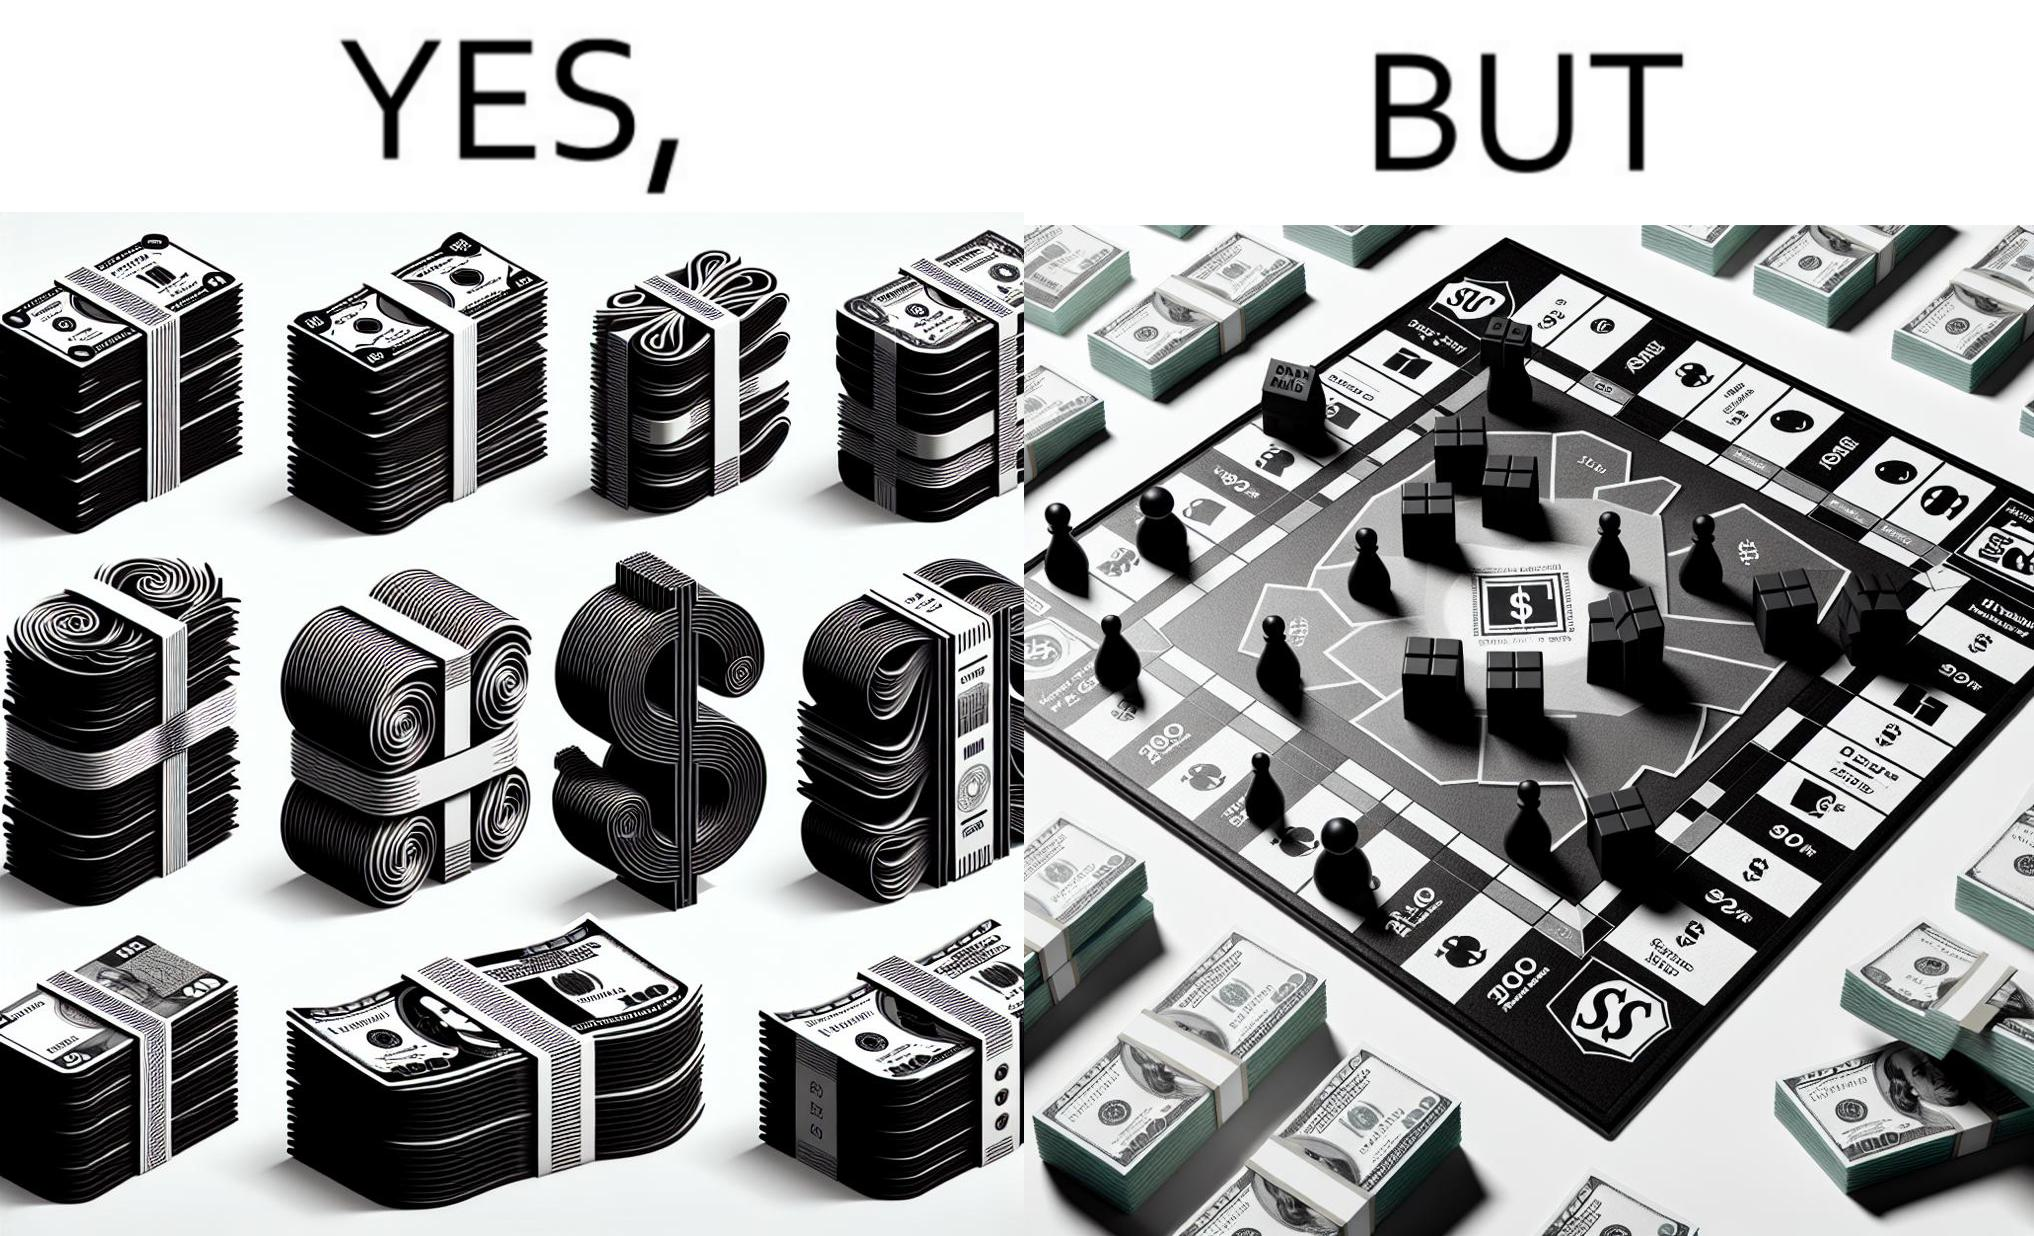Is there satirical content in this image? Yes, this image is satirical. 